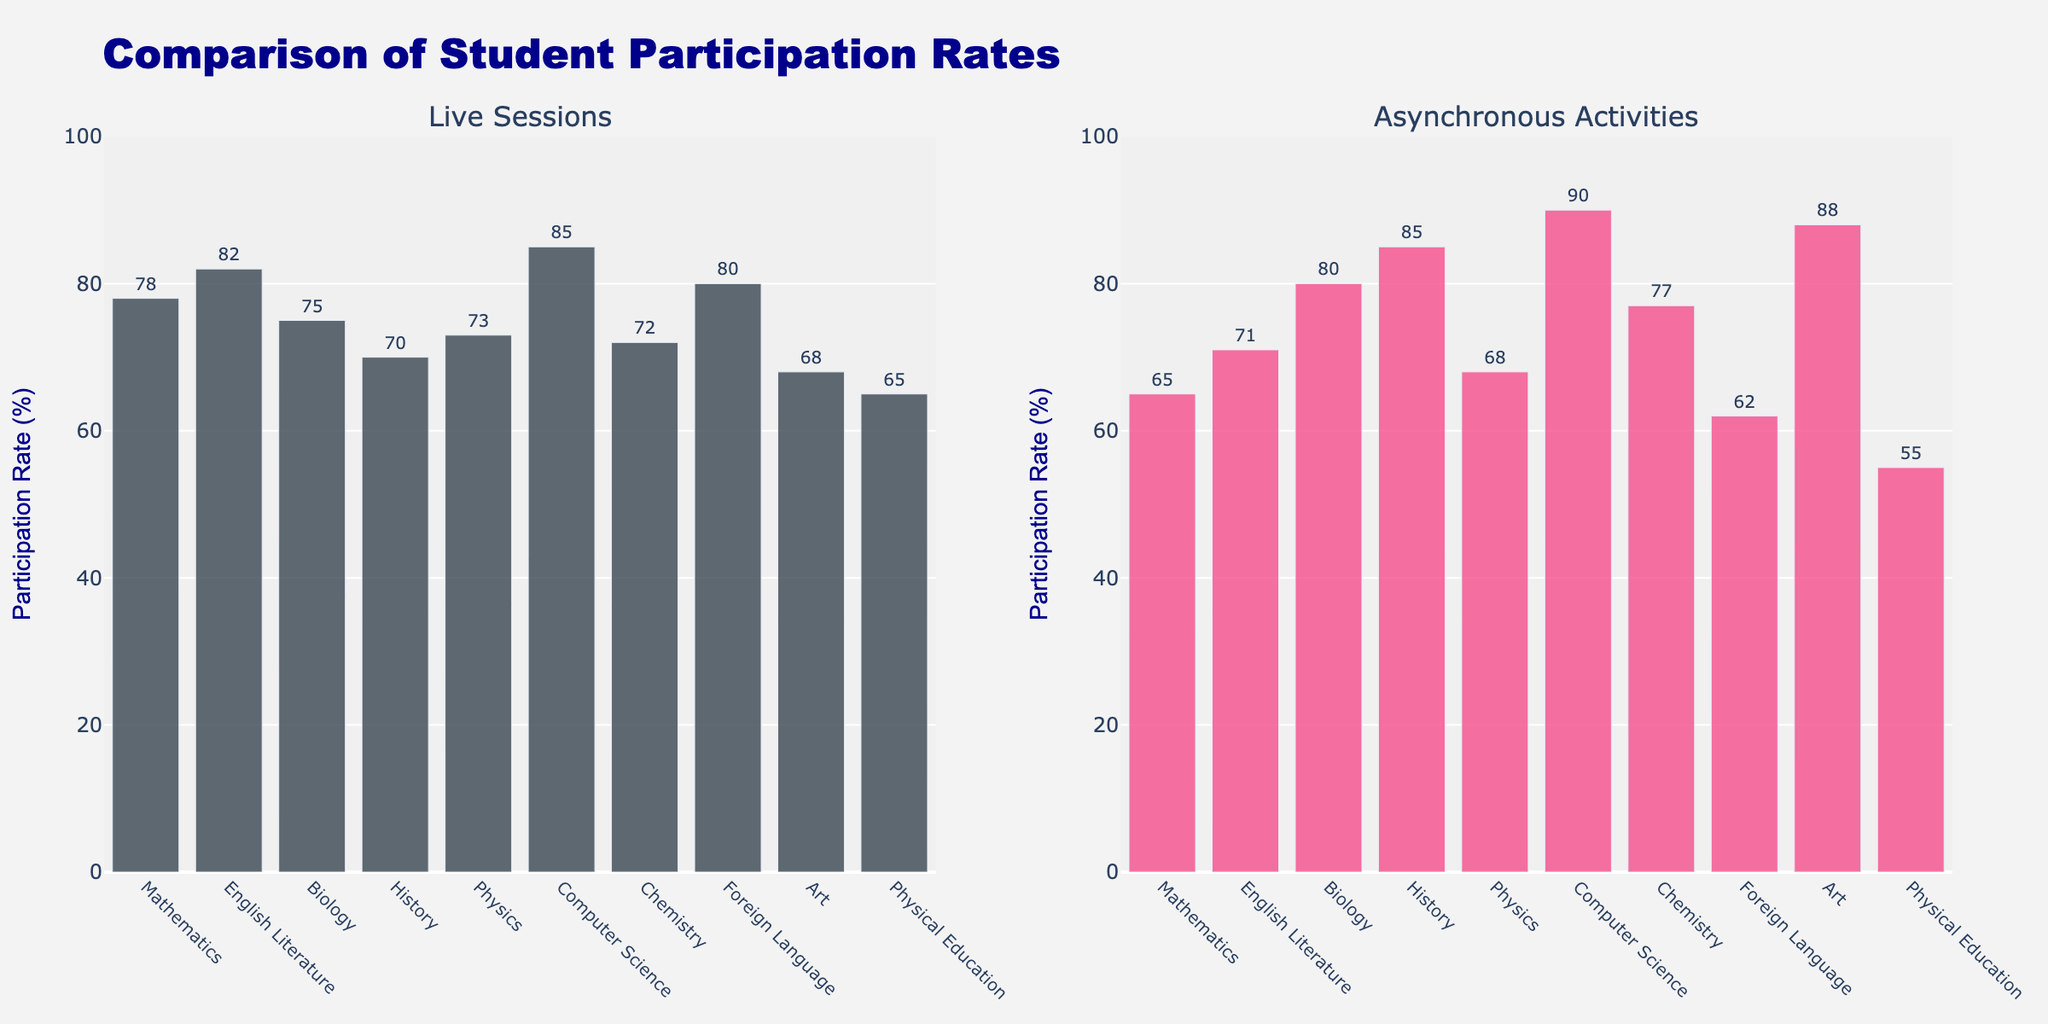What's the title of the figure? The title is provided at the top center of the figure.
Answer: NHL Metropolitan Division Ticket Prices How many teams are compared in the figure? The figure has bars for eight teams in each subplot, hence comparing eight teams.
Answer: 8 Which team has the highest ticket price in the Lower Bowl section? Check the subplot for the Lower Bowl section and compare the bar heights or values. The New York Rangers have the highest value at $225.
Answer: New York Rangers What's the price difference between the New Jersey Devils and the Philadelphia Flyers in the Upper Bowl section? Locate the bars for these two teams in the Upper Bowl section subplot. The values are $85 for the Devils and $80 for the Flyers. The difference is $85 - $80 = $5.
Answer: $5 Which team has the lowest price for Standing Room tickets? Find the subplot title "Standing Room" and compare the bar values. The Columbus Blue Jackets have the lowest at $35.
Answer: Columbus Blue Jackets What is the average ticket price for Club Level tickets across all teams? Sum the Club Level prices across all teams ($225 + $275 + $200 + $215 + $230 + $220 + $205 + $195 = $1,765), then divide by the number of teams (8). The average is $1,765 / 8 = $220.63.
Answer: $220.63 Which seating section shows the least variation in ticket prices among the teams? Visually compare the spread of bar heights across the four subplots. Standing Room prices appear to have the least variation, ranging from $35 to $60.
Answer: Standing Room Between the Carolina Hurricanes and Washington Capitals, who has the cheaper Lower Bowl tickets, and by how much? Find and compare the bar heights in the Lower Bowl subplot. The Hurricanes' price is $155, and the Capitals' is $170. The difference is $170 - $155 = $15, with Hurricanes being cheaper.
Answer: Carolina Hurricanes, $15 What is the total combined price for all seating sections for the New York Islanders? Sum the ticket prices for all sections for the Islanders ($150 + $200 + $75 + $40 = $465).
Answer: $465 